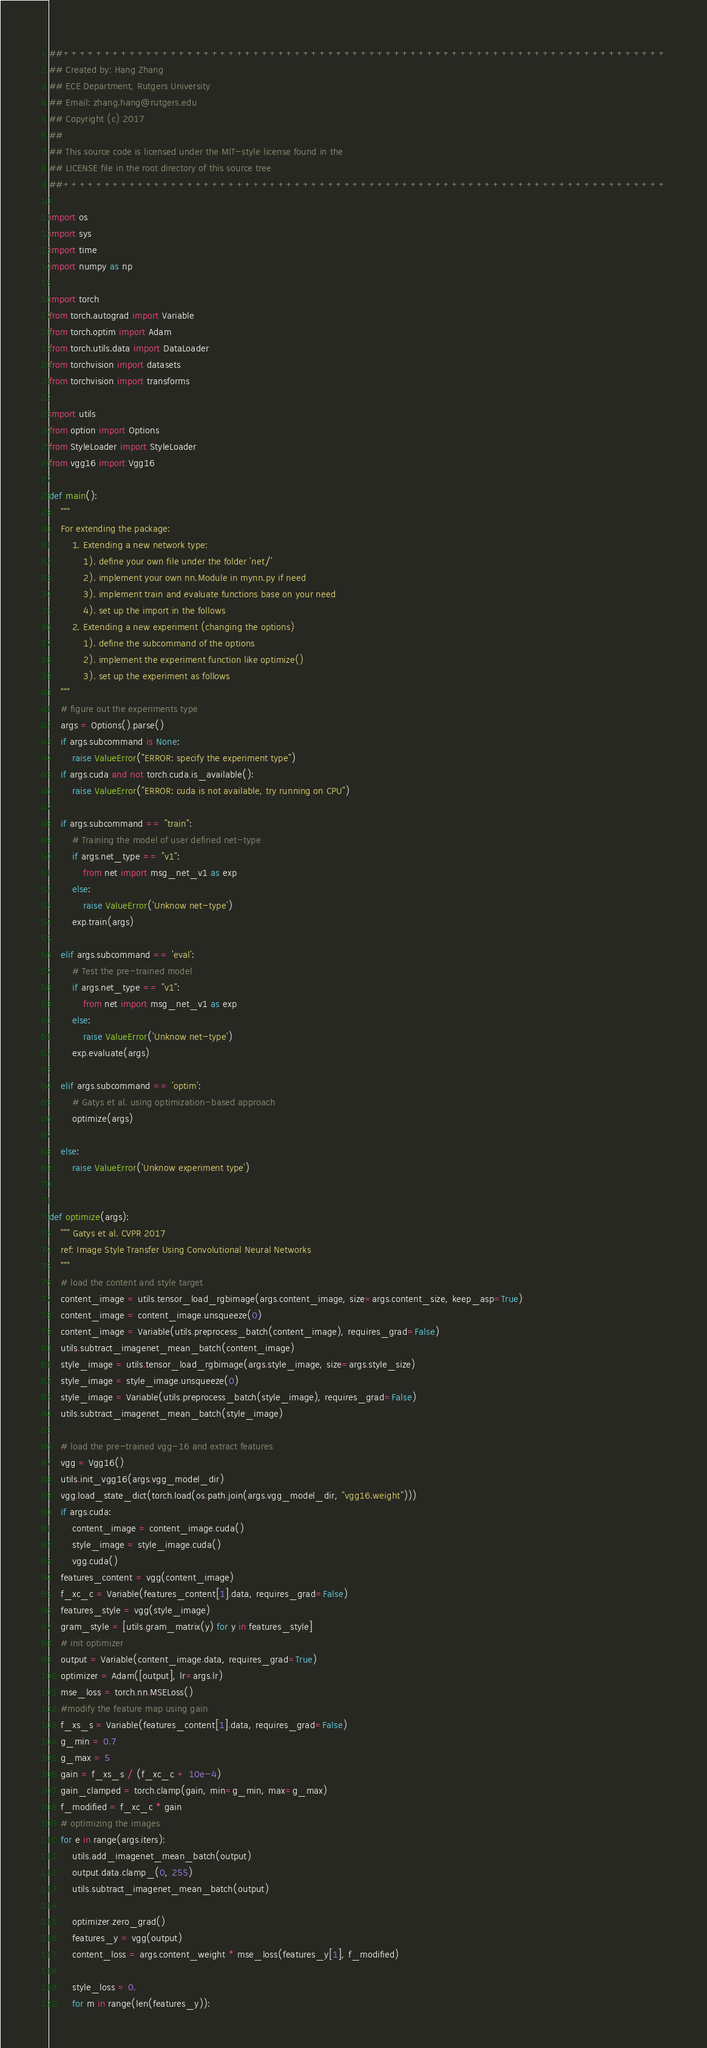Convert code to text. <code><loc_0><loc_0><loc_500><loc_500><_Python_>##+++++++++++++++++++++++++++++++++++++++++++++++++++++++++++++++++++++++++
## Created by: Hang Zhang
## ECE Department, Rutgers University
## Email: zhang.hang@rutgers.edu
## Copyright (c) 2017
##
## This source code is licensed under the MIT-style license found in the
## LICENSE file in the root directory of this source tree 
##+++++++++++++++++++++++++++++++++++++++++++++++++++++++++++++++++++++++++

import os
import sys
import time
import numpy as np

import torch
from torch.autograd import Variable
from torch.optim import Adam
from torch.utils.data import DataLoader
from torchvision import datasets
from torchvision import transforms

import utils
from option import Options
from StyleLoader import StyleLoader
from vgg16 import Vgg16

def main():
	"""
	For extending the package:
		1. Extending a new network type:
			1). define your own file under the folder 'net/' 
			2). implement your own nn.Module in mynn.py if need
			3). implement train and evaluate functions base on your need
			4). set up the import in the follows
		2. Extending a new experiment (changing the options)
			1). define the subcommand of the options
			2). implement the experiment function like optimize()
			3). set up the experiment as follows
	"""
	# figure out the experiments type
	args = Options().parse()
	if args.subcommand is None:
		raise ValueError("ERROR: specify the experiment type")
	if args.cuda and not torch.cuda.is_available():
		raise ValueError("ERROR: cuda is not available, try running on CPU")

	if args.subcommand == "train":
		# Training the model of user defined net-type
		if args.net_type == "v1":
			from net import msg_net_v1 as exp	
		else:
			raise ValueError('Unknow net-type')
		exp.train(args)

	elif args.subcommand == 'eval':
		# Test the pre-trained model
		if args.net_type == "v1":
			from net import msg_net_v1 as exp	
		else:
			raise ValueError('Unknow net-type')
		exp.evaluate(args)

	elif args.subcommand == 'optim':
		# Gatys et al. using optimization-based approach
		optimize(args)

	else:
		raise ValueError('Unknow experiment type')


def optimize(args):
	"""	Gatys et al. CVPR 2017
	ref: Image Style Transfer Using Convolutional Neural Networks
	"""
	# load the content and style target
	content_image = utils.tensor_load_rgbimage(args.content_image, size=args.content_size, keep_asp=True)
	content_image = content_image.unsqueeze(0)
	content_image = Variable(utils.preprocess_batch(content_image), requires_grad=False)
	utils.subtract_imagenet_mean_batch(content_image)
	style_image = utils.tensor_load_rgbimage(args.style_image, size=args.style_size)
	style_image = style_image.unsqueeze(0)	
	style_image = Variable(utils.preprocess_batch(style_image), requires_grad=False)
	utils.subtract_imagenet_mean_batch(style_image)

	# load the pre-trained vgg-16 and extract features
	vgg = Vgg16()
	utils.init_vgg16(args.vgg_model_dir)
	vgg.load_state_dict(torch.load(os.path.join(args.vgg_model_dir, "vgg16.weight")))
	if args.cuda:
		content_image = content_image.cuda()
		style_image = style_image.cuda()
		vgg.cuda()
	features_content = vgg(content_image)
	f_xc_c = Variable(features_content[1].data, requires_grad=False)
	features_style = vgg(style_image)
	gram_style = [utils.gram_matrix(y) for y in features_style]
	# init optimizer
	output = Variable(content_image.data, requires_grad=True)
	optimizer = Adam([output], lr=args.lr)
	mse_loss = torch.nn.MSELoss()
	#modify the feature map using gain
	f_xs_s = Variable(features_content[1].data, requires_grad=False)
	g_min = 0.7
	g_max = 5
	gain = f_xs_s / (f_xc_c + 10e-4)
	gain_clamped = torch.clamp(gain, min=g_min, max=g_max)
	f_modified = f_xc_c * gain
	# optimizing the images
	for e in range(args.iters):
		utils.add_imagenet_mean_batch(output)
		output.data.clamp_(0, 255)	
		utils.subtract_imagenet_mean_batch(output)

		optimizer.zero_grad()
		features_y = vgg(output)
		content_loss = args.content_weight * mse_loss(features_y[1], f_modified)

		style_loss = 0.
		for m in range(len(features_y)):</code> 